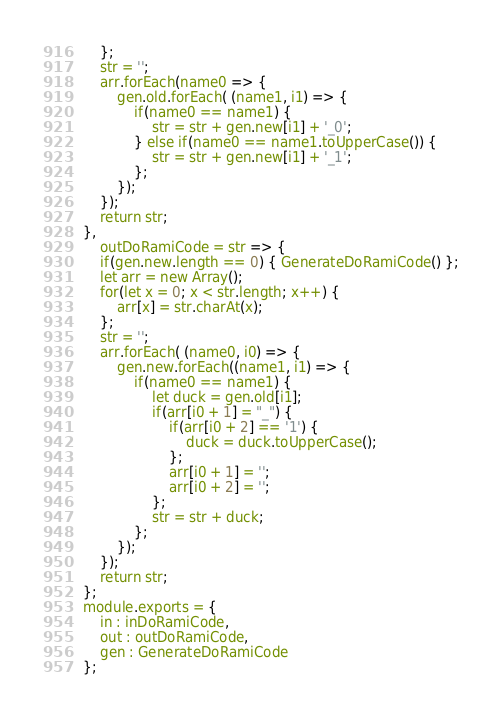Convert code to text. <code><loc_0><loc_0><loc_500><loc_500><_JavaScript_>	};
	str = '';
	arr.forEach(name0 => {
		gen.old.forEach( (name1, i1) => {
			if(name0 == name1) {
				str = str + gen.new[i1] + '_0';
			} else if(name0 == name1.toUpperCase()) {
				str = str + gen.new[i1] + '_1';
			};
		});
	});
	return str;
},
	outDoRamiCode = str => {
	if(gen.new.length == 0) { GenerateDoRamiCode() };
	let arr = new Array();
	for(let x = 0; x < str.length; x++) {
		arr[x] = str.charAt(x);
	};
	str = '';
	arr.forEach( (name0, i0) => {
		gen.new.forEach((name1, i1) => {
			if(name0 == name1) {
				let duck = gen.old[i1];
				if(arr[i0 + 1] = "_") {
					if(arr[i0 + 2] == '1') {
						duck = duck.toUpperCase();
					};
					arr[i0 + 1] = '';
					arr[i0 + 2] = '';
				};
				str = str + duck;
			};
		});
	});
	return str;
};
module.exports = {
	in : inDoRamiCode,
	out : outDoRamiCode,
	gen : GenerateDoRamiCode
};</code> 